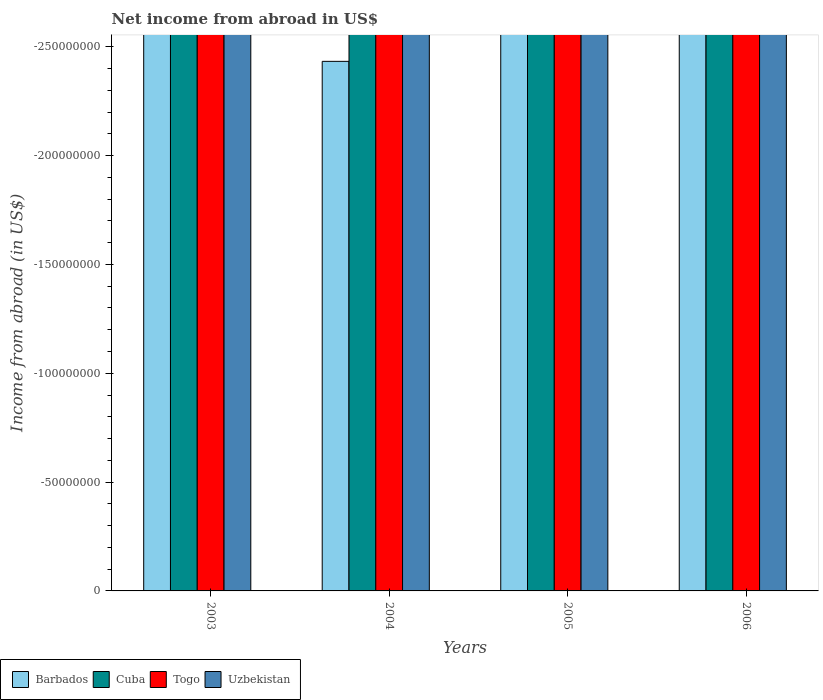Are the number of bars per tick equal to the number of legend labels?
Your answer should be compact. No. How many bars are there on the 1st tick from the left?
Your answer should be very brief. 0. What is the label of the 2nd group of bars from the left?
Your answer should be very brief. 2004. What is the net income from abroad in Uzbekistan in 2004?
Your answer should be compact. 0. Across all years, what is the minimum net income from abroad in Barbados?
Your answer should be very brief. 0. What is the total net income from abroad in Barbados in the graph?
Your answer should be very brief. 0. What is the difference between the net income from abroad in Barbados in 2003 and the net income from abroad in Togo in 2005?
Offer a very short reply. 0. In how many years, is the net income from abroad in Barbados greater than -40000000 US$?
Ensure brevity in your answer.  0. In how many years, is the net income from abroad in Uzbekistan greater than the average net income from abroad in Uzbekistan taken over all years?
Your answer should be compact. 0. Is it the case that in every year, the sum of the net income from abroad in Cuba and net income from abroad in Togo is greater than the net income from abroad in Uzbekistan?
Ensure brevity in your answer.  No. Are all the bars in the graph horizontal?
Provide a succinct answer. No. What is the difference between two consecutive major ticks on the Y-axis?
Make the answer very short. 5.00e+07. Are the values on the major ticks of Y-axis written in scientific E-notation?
Make the answer very short. No. Does the graph contain any zero values?
Offer a terse response. Yes. Does the graph contain grids?
Offer a very short reply. No. What is the title of the graph?
Your answer should be compact. Net income from abroad in US$. Does "Philippines" appear as one of the legend labels in the graph?
Your answer should be very brief. No. What is the label or title of the Y-axis?
Offer a terse response. Income from abroad (in US$). What is the Income from abroad (in US$) in Barbados in 2003?
Offer a terse response. 0. What is the Income from abroad (in US$) of Togo in 2003?
Your response must be concise. 0. What is the Income from abroad (in US$) in Uzbekistan in 2003?
Offer a terse response. 0. What is the Income from abroad (in US$) of Cuba in 2004?
Make the answer very short. 0. What is the Income from abroad (in US$) of Uzbekistan in 2004?
Keep it short and to the point. 0. What is the Income from abroad (in US$) in Togo in 2005?
Make the answer very short. 0. What is the Income from abroad (in US$) in Uzbekistan in 2006?
Make the answer very short. 0. What is the total Income from abroad (in US$) in Togo in the graph?
Provide a succinct answer. 0. What is the average Income from abroad (in US$) of Barbados per year?
Your answer should be compact. 0. What is the average Income from abroad (in US$) in Cuba per year?
Provide a short and direct response. 0. What is the average Income from abroad (in US$) of Togo per year?
Give a very brief answer. 0. What is the average Income from abroad (in US$) in Uzbekistan per year?
Offer a terse response. 0. 